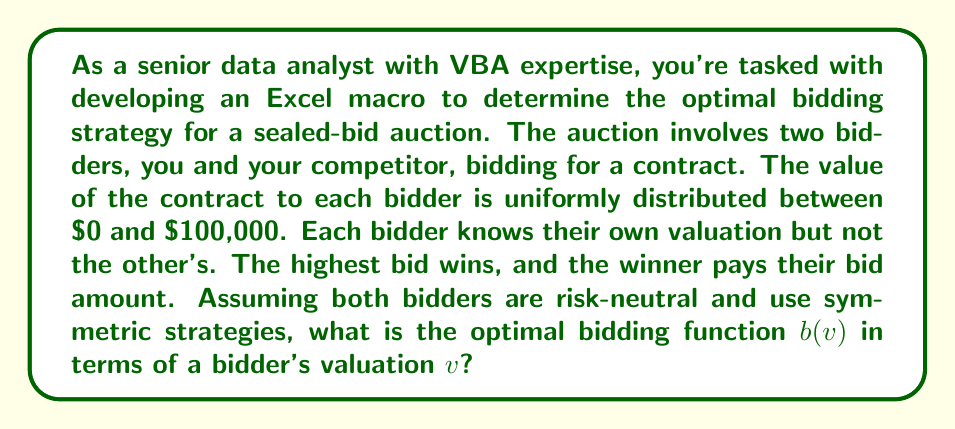What is the answer to this math problem? To solve this problem, we'll use the principles of game theory and auction theory. Let's approach this step-by-step:

1) In a symmetric equilibrium, both bidders use the same bidding function $b(v)$.

2) For a uniform distribution on $[0, 100000]$, the cumulative distribution function is:

   $F(v) = \frac{v}{100000}$

3) In a first-price sealed-bid auction with two risk-neutral bidders and independent private values, the optimal bidding function is given by:

   $b(v) = E[Y|Y < v]$

   where $Y$ is the other bidder's valuation.

4) For a uniform distribution, $E[Y|Y < v] = \frac{v}{2}$

5) Therefore, the optimal bidding function is:

   $b(v) = \frac{v}{2}$

This means that the optimal strategy is to bid half of your valuation.

To implement this in VBA, you could create a function like:

```vba
Function OptimalBid(valuation As Double) As Double
    OptimalBid = valuation / 2
End Function
```

This function could then be used in an Excel worksheet to calculate optimal bids for various valuations.
Answer: The optimal bidding function is $b(v) = \frac{v}{2}$, where $v$ is the bidder's valuation of the contract. 